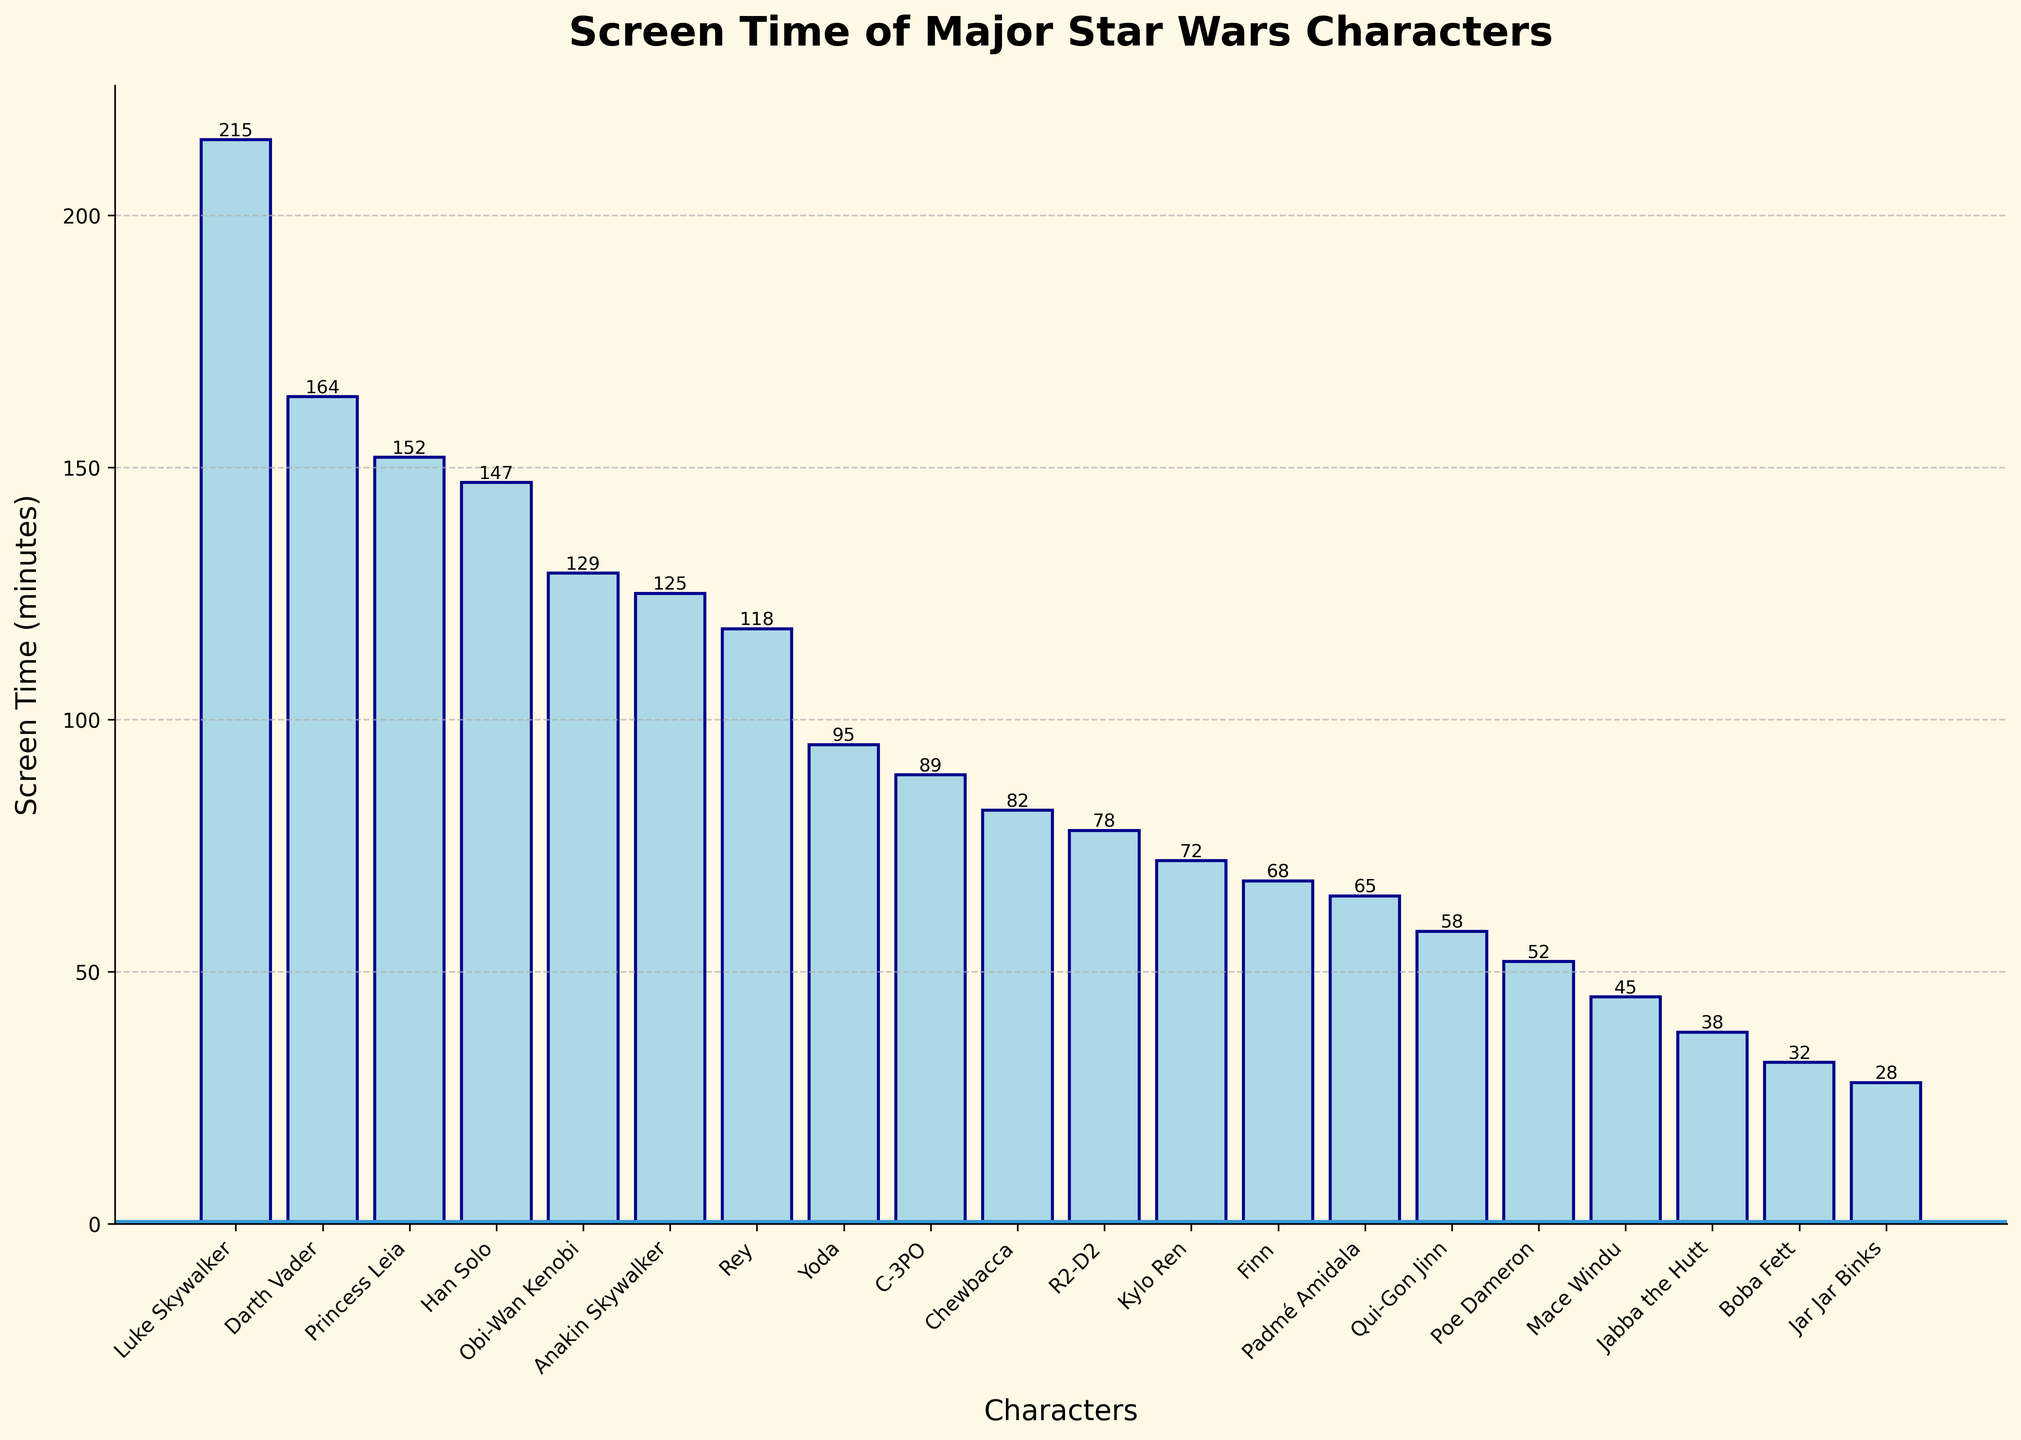Which character has the highest screen time? Look at the bar with the greatest height, which represents the character with the most screen time. The tallest bar is for Luke Skywalker.
Answer: Luke Skywalker What is the difference in screen time between Darth Vader and Han Solo? Find the heights of the bars for Darth Vader and Han Solo and subtract the value for Han Solo from Darth Vader. Darth Vader has 164 minutes, and Han Solo has 147 minutes. 164 - 147 = 17 minutes.
Answer: 17 minutes Which characters have more screen time than Yoda but less than Princess Leia? Identify the characters with bar heights between the values for Yoda (95 minutes) and Princess Leia (152 minutes). These are Obi-Wan Kenobi (129 mins), Anakin Skywalker (125 mins), and Rey (118 mins).
Answer: Obi-Wan Kenobi, Anakin Skywalker, Rey What is the total screen time of characters who have more than 100 minutes? Sum the screen time of characters with bars taller than 100 minutes. These are Luke Skywalker (215 mins), Darth Vader (164 mins), Princess Leia (152 mins), Han Solo (147 mins), Obi-Wan Kenobi (129 mins), and Anakin Skywalker (125 mins). 215 + 164 + 152 + 147 + 129 + 125 = 932 minutes.
Answer: 932 minutes How does Rey's screen time compare to Finn's? Compare the heights of the bars for Rey and Finn. Rey has a taller bar than Finn. Rey's screen time is 118 minutes, whereas Finn's is 68 minutes. Hence Rey has more screen time.
Answer: Rey has more screen time Which character has the least screen time and what is it? Look at the shortest bar, which represents the character with the least screen time. The shortest bar is for Jar Jar Binks.
Answer: Jar Jar Binks with 28 minutes If you combine the screen time of Obi-Wan Kenobi and Qui-Gon Jinn, how much screen time do you get? Add the screen time values of Obi-Wan Kenobi and Qui-Gon Jinn. Obi-Wan Kenobi has 129 minutes, and Qui-Gon Jinn has 58 minutes. 129 + 58 = 187 minutes.
Answer: 187 minutes Are there more characters with screen time above or below 50 minutes? Count the characters with bars higher than 50 minutes and those with bars under 50 minutes. There are 15 characters with more than 50 minutes and 5 characters with less than 50 minutes.
Answer: More characters above 50 minutes What visual cue indicates the screen time values of the characters? Identify the visual elements that display the screen time values. The height of the bars and the numerical labels on top indicate the screen time.
Answer: Height of the bars and numerical labels 